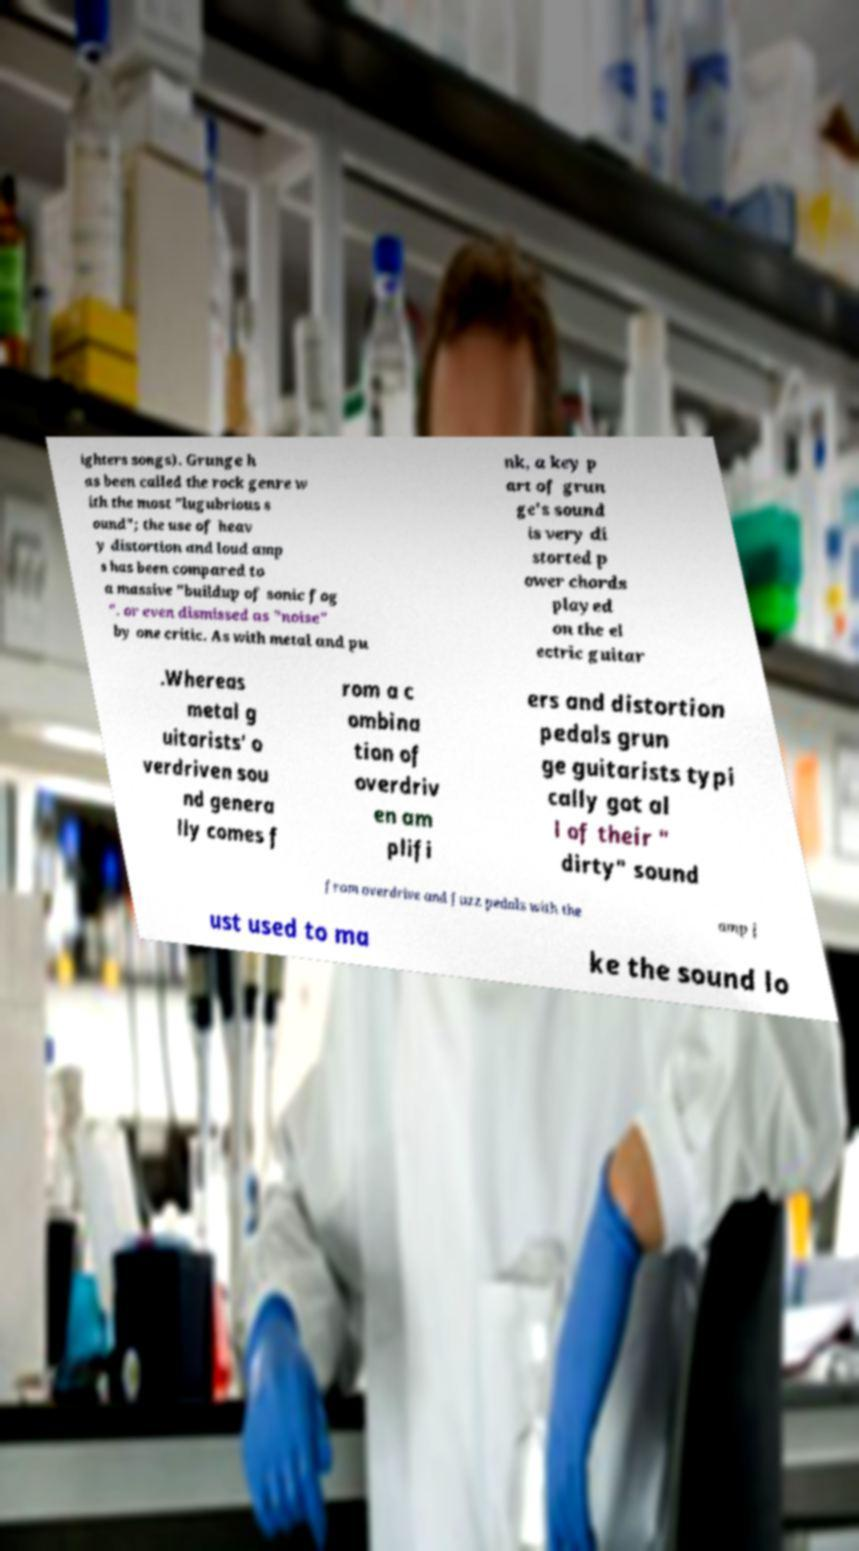Could you extract and type out the text from this image? ighters songs). Grunge h as been called the rock genre w ith the most "lugubrious s ound"; the use of heav y distortion and loud amp s has been compared to a massive "buildup of sonic fog ". or even dismissed as "noise" by one critic. As with metal and pu nk, a key p art of grun ge's sound is very di storted p ower chords played on the el ectric guitar .Whereas metal g uitarists' o verdriven sou nd genera lly comes f rom a c ombina tion of overdriv en am plifi ers and distortion pedals grun ge guitarists typi cally got al l of their " dirty" sound from overdrive and fuzz pedals with the amp j ust used to ma ke the sound lo 